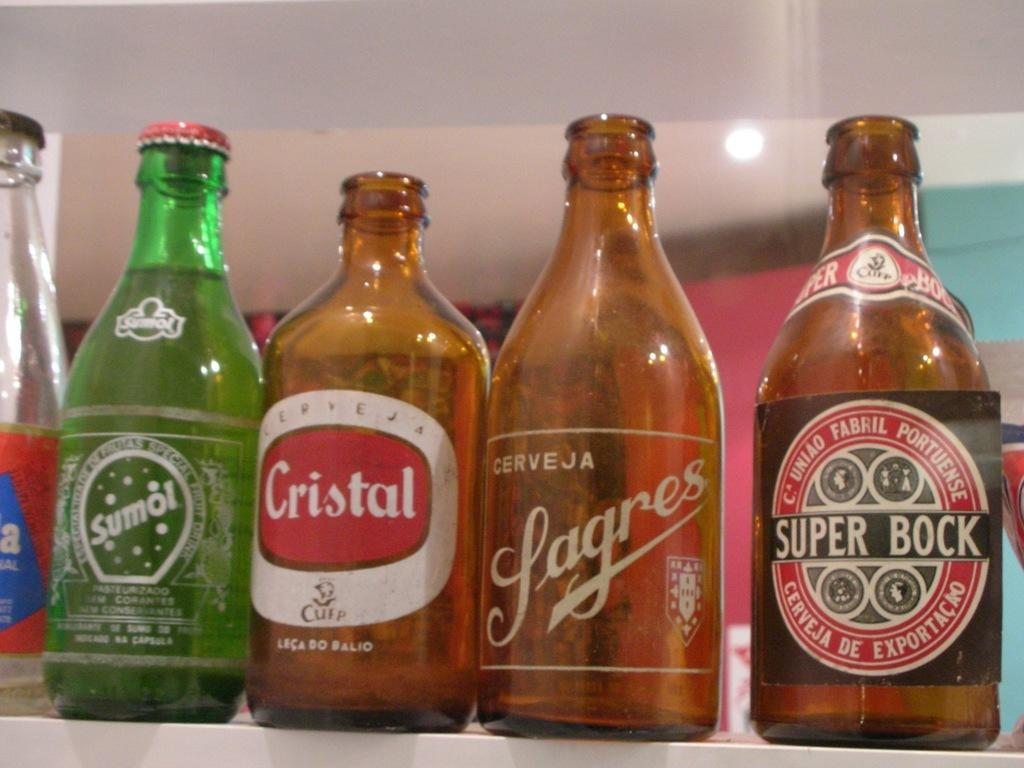<image>
Render a clear and concise summary of the photo. Four open and empty bottle including Sumol and Cristal 